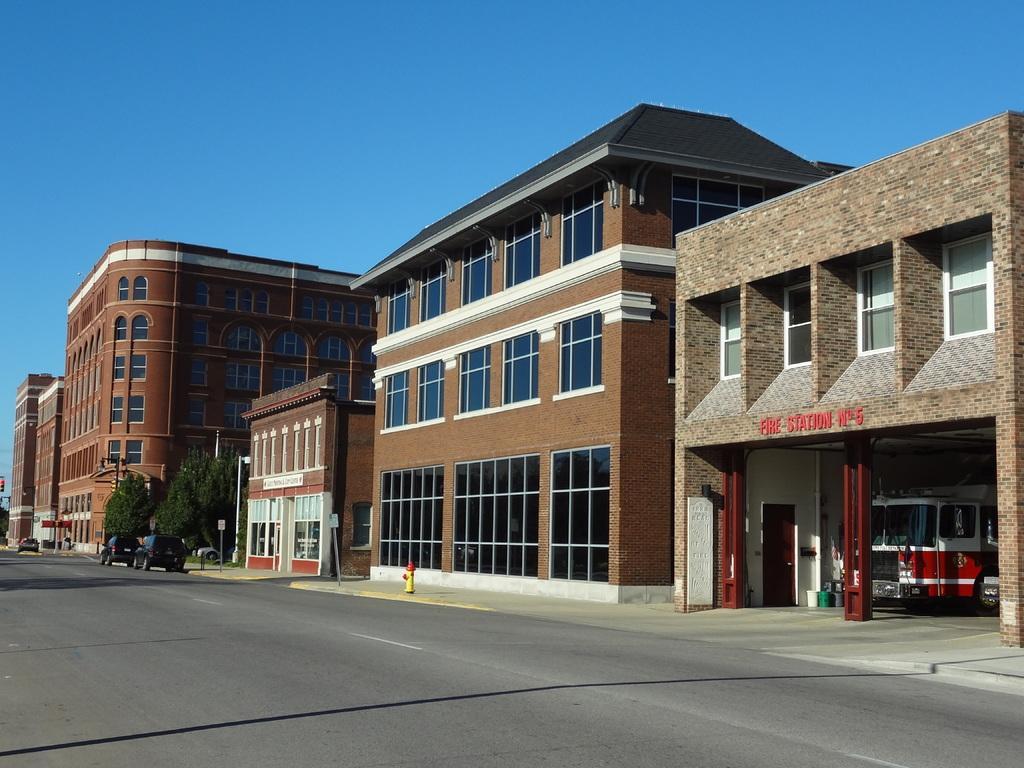Describe this image in one or two sentences. In this image there are few buildings visible in front of the road , on the road trees and vehicles visible , at the top there is the sky and there is a vehicle visible on the right side under the building. 